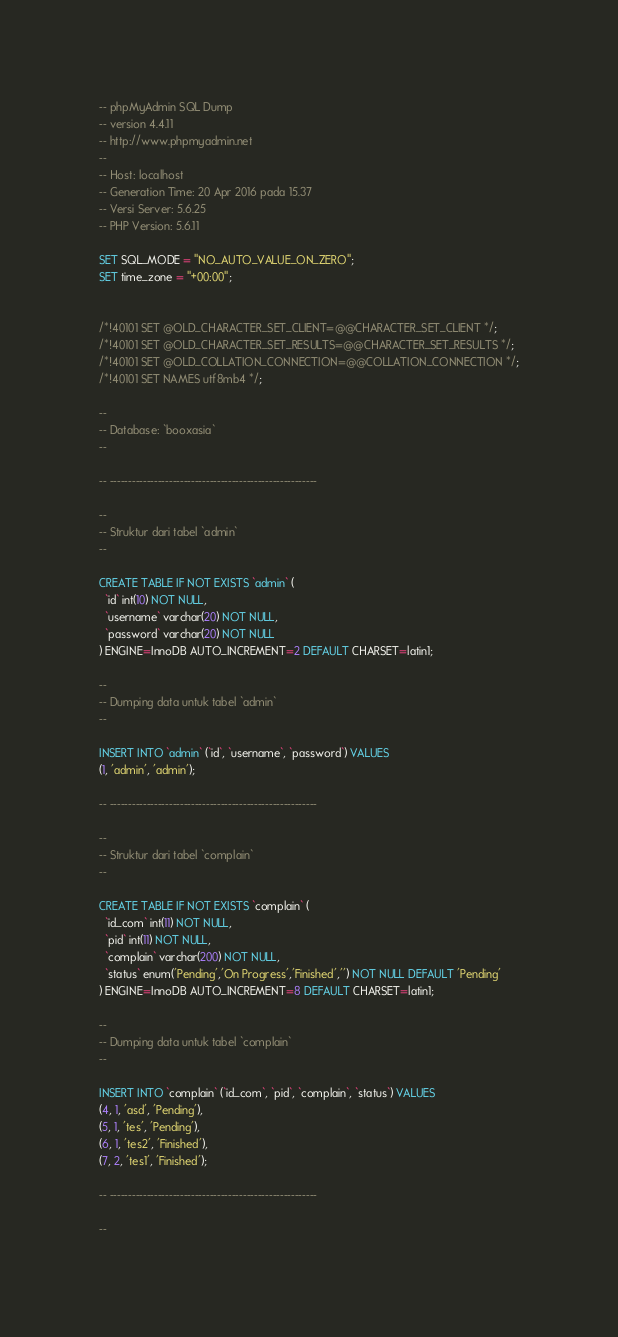Convert code to text. <code><loc_0><loc_0><loc_500><loc_500><_SQL_>-- phpMyAdmin SQL Dump
-- version 4.4.11
-- http://www.phpmyadmin.net
--
-- Host: localhost
-- Generation Time: 20 Apr 2016 pada 15.37
-- Versi Server: 5.6.25
-- PHP Version: 5.6.11

SET SQL_MODE = "NO_AUTO_VALUE_ON_ZERO";
SET time_zone = "+00:00";


/*!40101 SET @OLD_CHARACTER_SET_CLIENT=@@CHARACTER_SET_CLIENT */;
/*!40101 SET @OLD_CHARACTER_SET_RESULTS=@@CHARACTER_SET_RESULTS */;
/*!40101 SET @OLD_COLLATION_CONNECTION=@@COLLATION_CONNECTION */;
/*!40101 SET NAMES utf8mb4 */;

--
-- Database: `booxasia`
--

-- --------------------------------------------------------

--
-- Struktur dari tabel `admin`
--

CREATE TABLE IF NOT EXISTS `admin` (
  `id` int(10) NOT NULL,
  `username` varchar(20) NOT NULL,
  `password` varchar(20) NOT NULL
) ENGINE=InnoDB AUTO_INCREMENT=2 DEFAULT CHARSET=latin1;

--
-- Dumping data untuk tabel `admin`
--

INSERT INTO `admin` (`id`, `username`, `password`) VALUES
(1, 'admin', 'admin');

-- --------------------------------------------------------

--
-- Struktur dari tabel `complain`
--

CREATE TABLE IF NOT EXISTS `complain` (
  `id_com` int(11) NOT NULL,
  `pid` int(11) NOT NULL,
  `complain` varchar(200) NOT NULL,
  `status` enum('Pending','On Progress','Finished','') NOT NULL DEFAULT 'Pending'
) ENGINE=InnoDB AUTO_INCREMENT=8 DEFAULT CHARSET=latin1;

--
-- Dumping data untuk tabel `complain`
--

INSERT INTO `complain` (`id_com`, `pid`, `complain`, `status`) VALUES
(4, 1, 'asd', 'Pending'),
(5, 1, 'tes', 'Pending'),
(6, 1, 'tes2', 'Finished'),
(7, 2, 'tes1', 'Finished');

-- --------------------------------------------------------

--</code> 